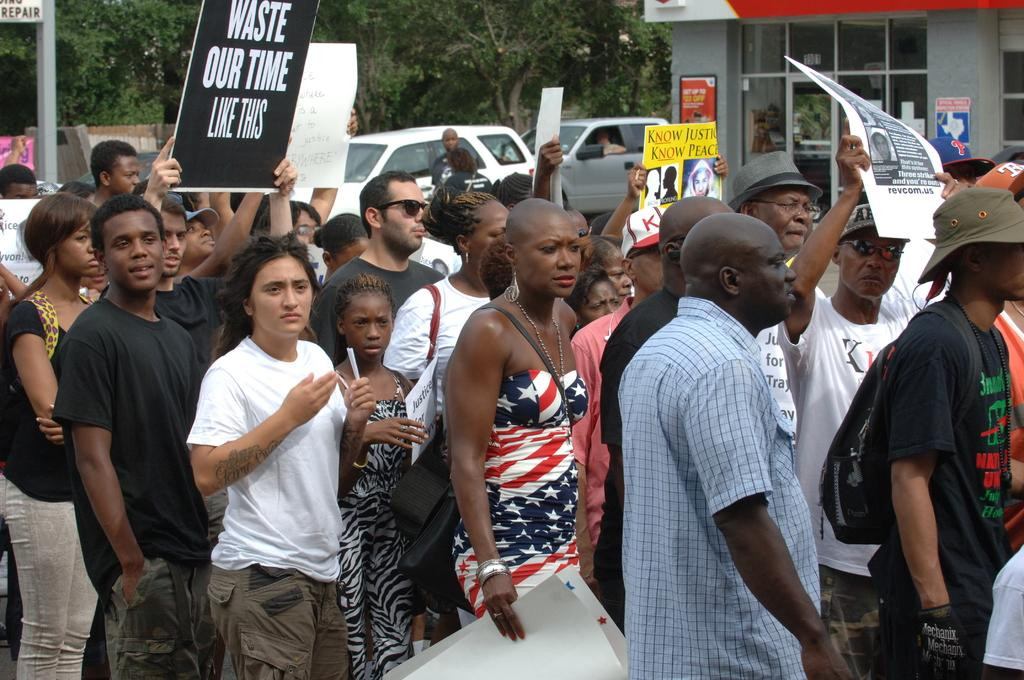How many people are in the image? There is a group of people in the image, but the exact number cannot be determined from the provided facts. What are some people holding in the image? Some people are holding posters in the image. What can be seen in the background of the image? There are vehicles, at least one building, and trees in the background of the image. What else is visible in the image? There are boards visible in the image. What type of arithmetic problem is being solved on the rod in the image? There is no rod or arithmetic problem present in the image. What kind of apparatus is being used by the people in the image? The provided facts do not mention any specific apparatus being used by the people in the image. 